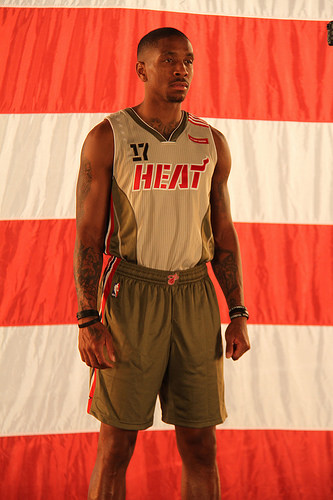<image>
Is the man behind the cloth? Yes. From this viewpoint, the man is positioned behind the cloth, with the cloth partially or fully occluding the man. Where is the cloth in relation to the man? Is it in front of the man? No. The cloth is not in front of the man. The spatial positioning shows a different relationship between these objects. 